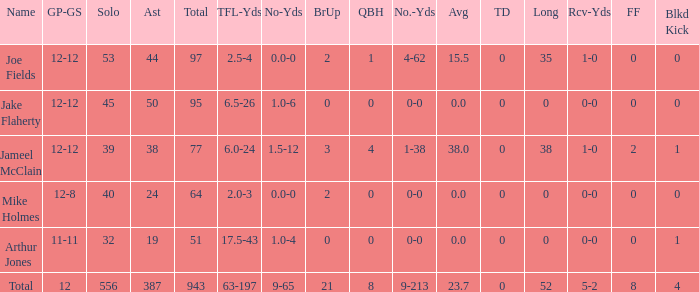For the player with a 23.7 average, how many tackle assists do they have? 387.0. 